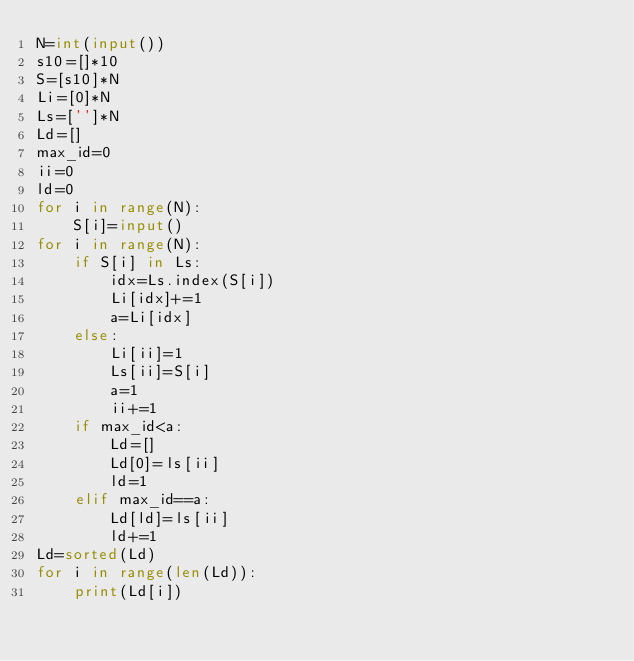Convert code to text. <code><loc_0><loc_0><loc_500><loc_500><_Python_>N=int(input())
s10=[]*10
S=[s10]*N
Li=[0]*N
Ls=['']*N
Ld=[]
max_id=0
ii=0
ld=0
for i in range(N):
    S[i]=input()
for i in range(N):
    if S[i] in Ls:
        idx=Ls.index(S[i])
        Li[idx]+=1
        a=Li[idx]
    else:
        Li[ii]=1
        Ls[ii]=S[i]
        a=1
        ii+=1
    if max_id<a:
        Ld=[]
        Ld[0]=ls[ii]
        ld=1
    elif max_id==a:
        Ld[ld]=ls[ii]
        ld+=1
Ld=sorted(Ld)
for i in range(len(Ld)):
    print(Ld[i])
</code> 